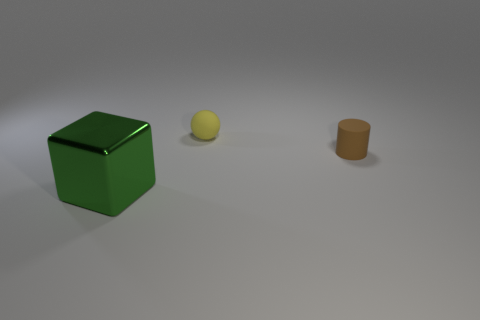Add 1 brown things. How many objects exist? 4 Subtract all cylinders. How many objects are left? 2 Subtract 0 red blocks. How many objects are left? 3 Subtract all small brown matte things. Subtract all tiny rubber objects. How many objects are left? 0 Add 3 small brown rubber objects. How many small brown rubber objects are left? 4 Add 1 small rubber blocks. How many small rubber blocks exist? 1 